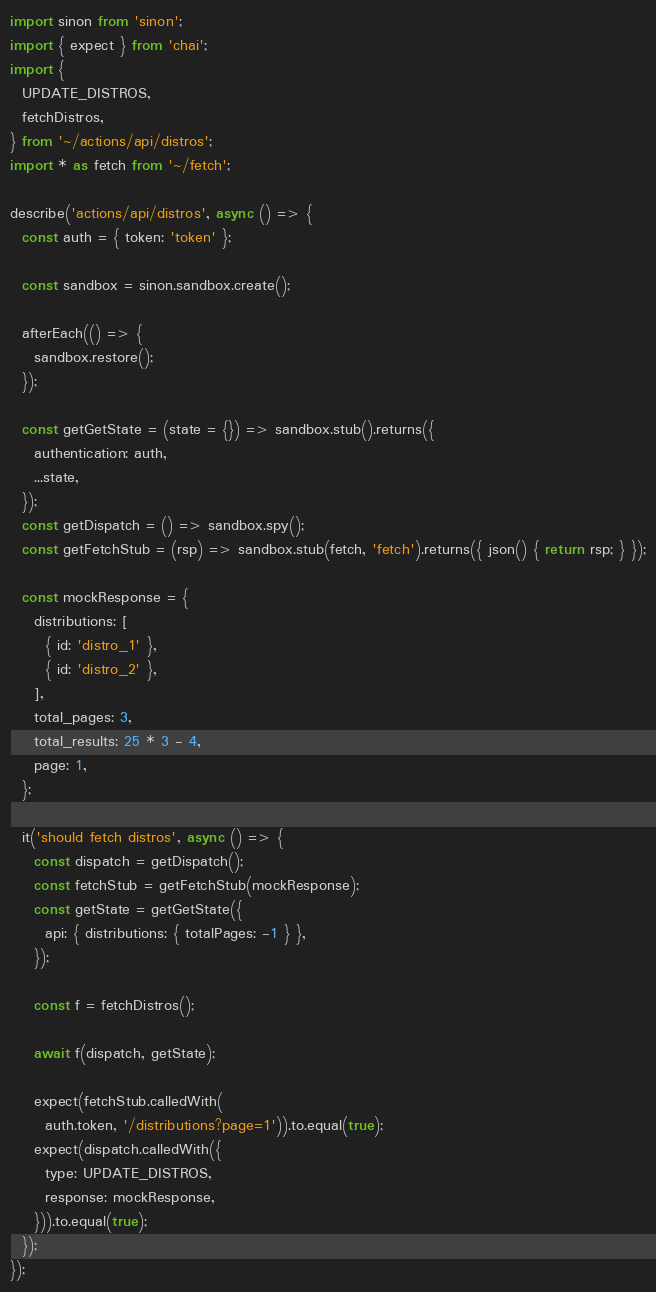<code> <loc_0><loc_0><loc_500><loc_500><_JavaScript_>import sinon from 'sinon';
import { expect } from 'chai';
import {
  UPDATE_DISTROS,
  fetchDistros,
} from '~/actions/api/distros';
import * as fetch from '~/fetch';

describe('actions/api/distros', async () => {
  const auth = { token: 'token' };

  const sandbox = sinon.sandbox.create();

  afterEach(() => {
    sandbox.restore();
  });

  const getGetState = (state = {}) => sandbox.stub().returns({
    authentication: auth,
    ...state,
  });
  const getDispatch = () => sandbox.spy();
  const getFetchStub = (rsp) => sandbox.stub(fetch, 'fetch').returns({ json() { return rsp; } });

  const mockResponse = {
    distributions: [
      { id: 'distro_1' },
      { id: 'distro_2' },
    ],
    total_pages: 3,
    total_results: 25 * 3 - 4,
    page: 1,
  };

  it('should fetch distros', async () => {
    const dispatch = getDispatch();
    const fetchStub = getFetchStub(mockResponse);
    const getState = getGetState({
      api: { distributions: { totalPages: -1 } },
    });

    const f = fetchDistros();

    await f(dispatch, getState);

    expect(fetchStub.calledWith(
      auth.token, '/distributions?page=1')).to.equal(true);
    expect(dispatch.calledWith({
      type: UPDATE_DISTROS,
      response: mockResponse,
    })).to.equal(true);
  });
});
</code> 